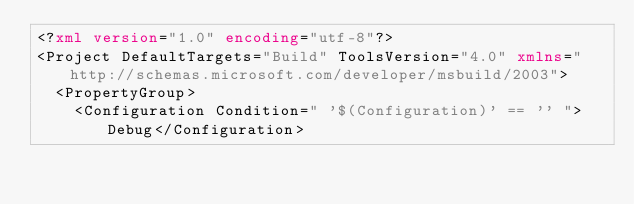<code> <loc_0><loc_0><loc_500><loc_500><_XML_><?xml version="1.0" encoding="utf-8"?>
<Project DefaultTargets="Build" ToolsVersion="4.0" xmlns="http://schemas.microsoft.com/developer/msbuild/2003">
  <PropertyGroup>
    <Configuration Condition=" '$(Configuration)' == '' ">Debug</Configuration></code> 